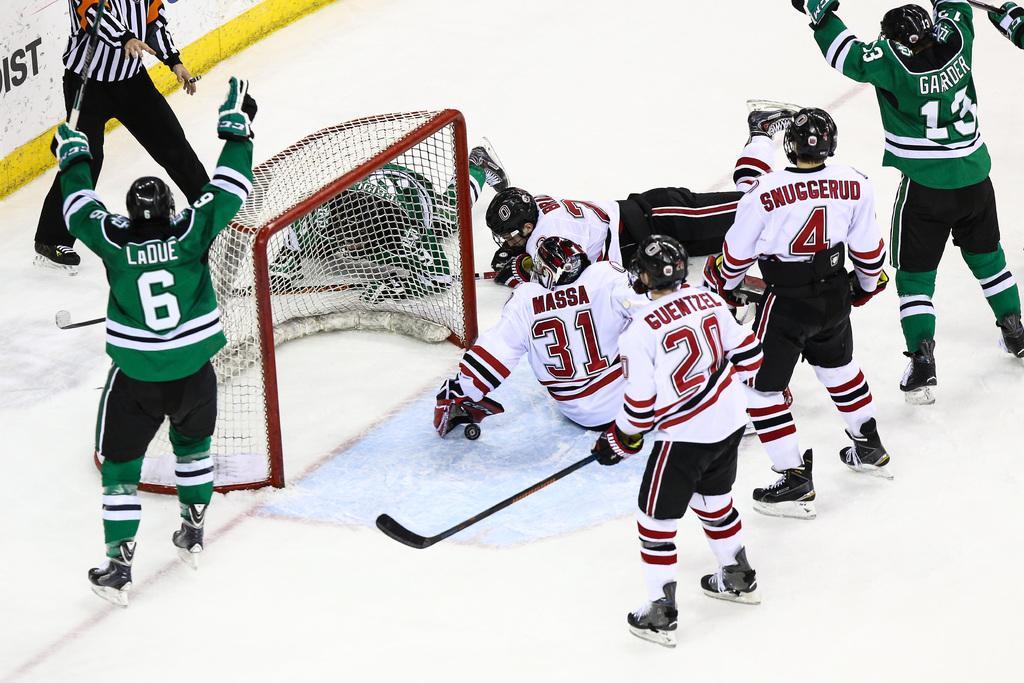Could you give a brief overview of what you see in this image? In this picture we can see two people holding ice hockey sticks. We can see a goalpost, a few people wearing ice skates, other objects and the text on the wall. 